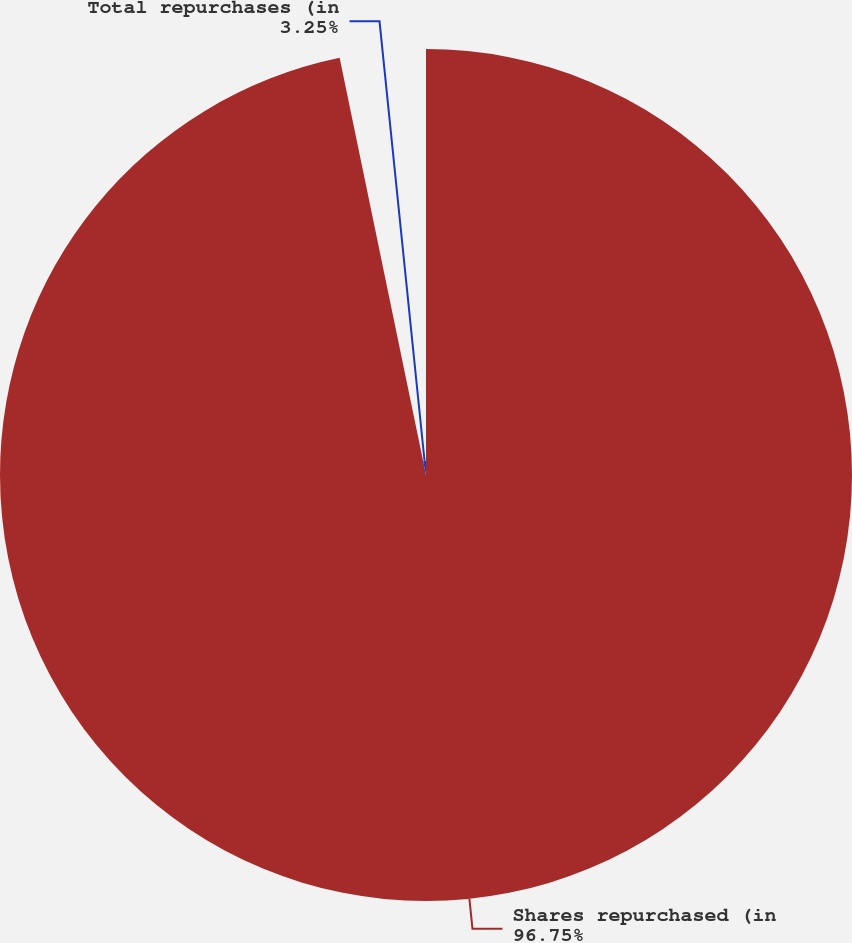Convert chart. <chart><loc_0><loc_0><loc_500><loc_500><pie_chart><fcel>Shares repurchased (in<fcel>Total repurchases (in<nl><fcel>96.75%<fcel>3.25%<nl></chart> 